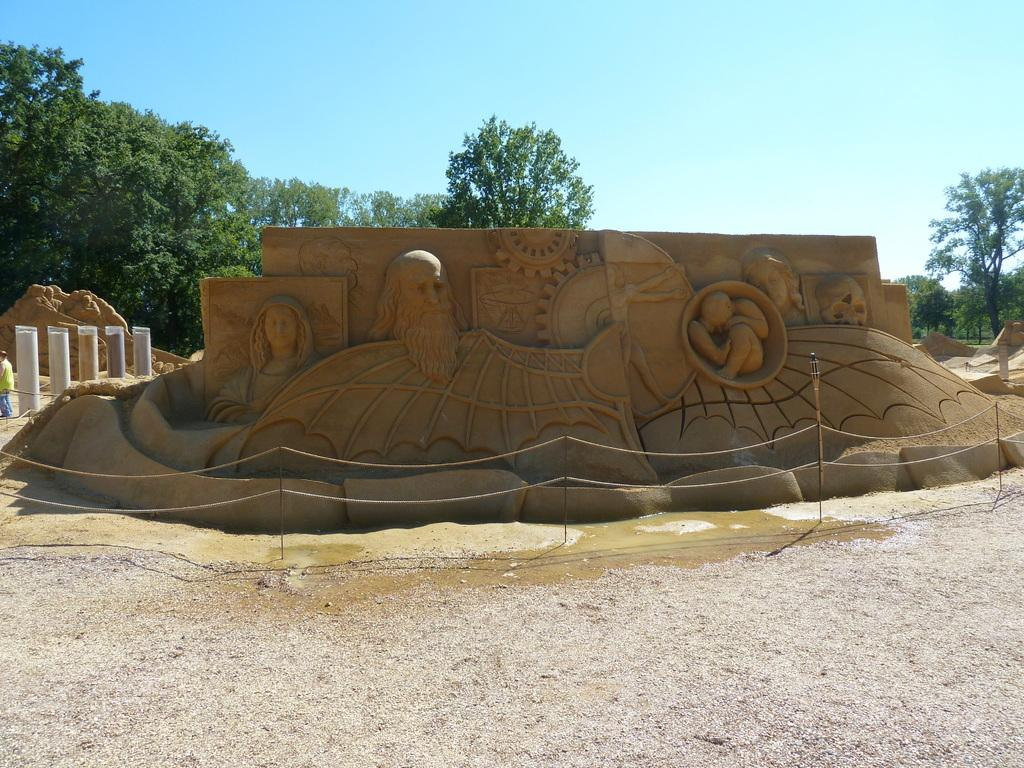What is the main subject of the image? There is a sand sculpture at the center of the image. What can be seen in the background of the image? There are trees and the sky visible in the background of the image. What type of vest is being worn by the hospital in the image? There is no hospital or vest present in the image; it features a sand sculpture and natural background elements. 